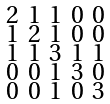Convert formula to latex. <formula><loc_0><loc_0><loc_500><loc_500>\begin{smallmatrix} 2 & 1 & 1 & 0 & 0 \\ 1 & 2 & 1 & 0 & 0 \\ 1 & 1 & 3 & 1 & 1 \\ 0 & 0 & 1 & 3 & 0 \\ 0 & 0 & 1 & 0 & 3 \end{smallmatrix}</formula> 